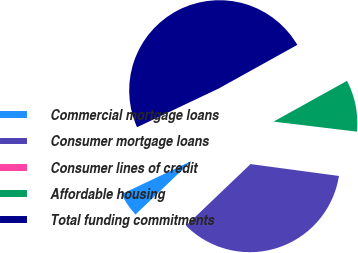Convert chart to OTSL. <chart><loc_0><loc_0><loc_500><loc_500><pie_chart><fcel>Commercial mortgage loans<fcel>Consumer mortgage loans<fcel>Consumer lines of credit<fcel>Affordable housing<fcel>Total funding commitments<nl><fcel>5.09%<fcel>35.74%<fcel>0.22%<fcel>9.97%<fcel>48.98%<nl></chart> 